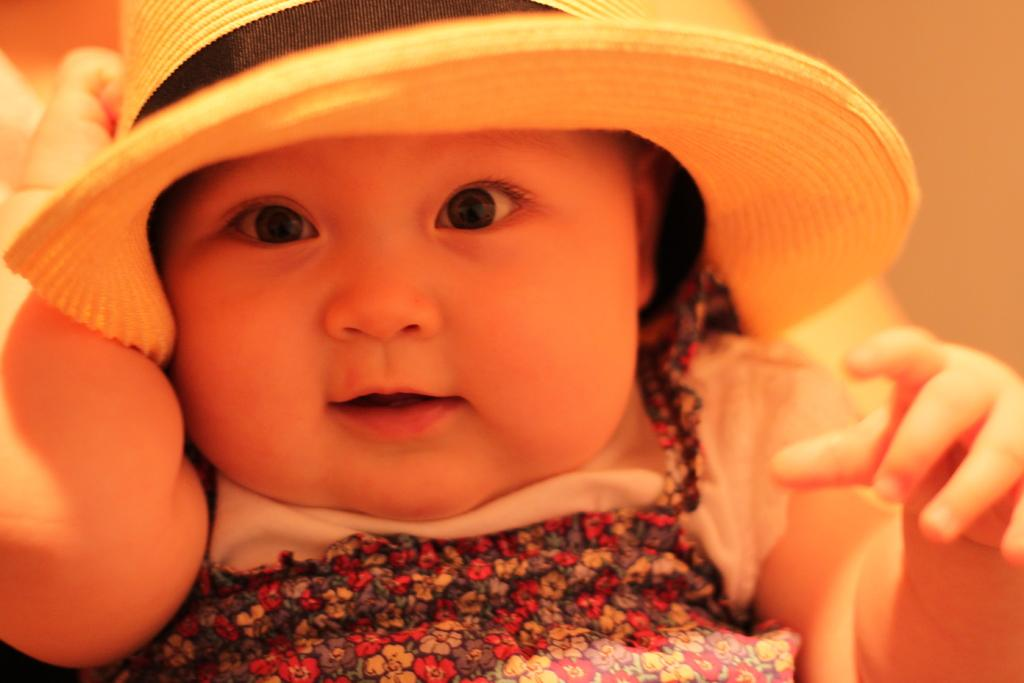What is the main subject of the picture? The main subject of the picture is a baby. What is the baby wearing on her head? The baby is wearing a hat on her head. How would you describe the background of the image? The background of the image is blurred. Is the baby stuck in quicksand in the image? No, there is no quicksand present in the image. What type of island can be seen in the background of the image? There is no island visible in the image; the background is blurred. 